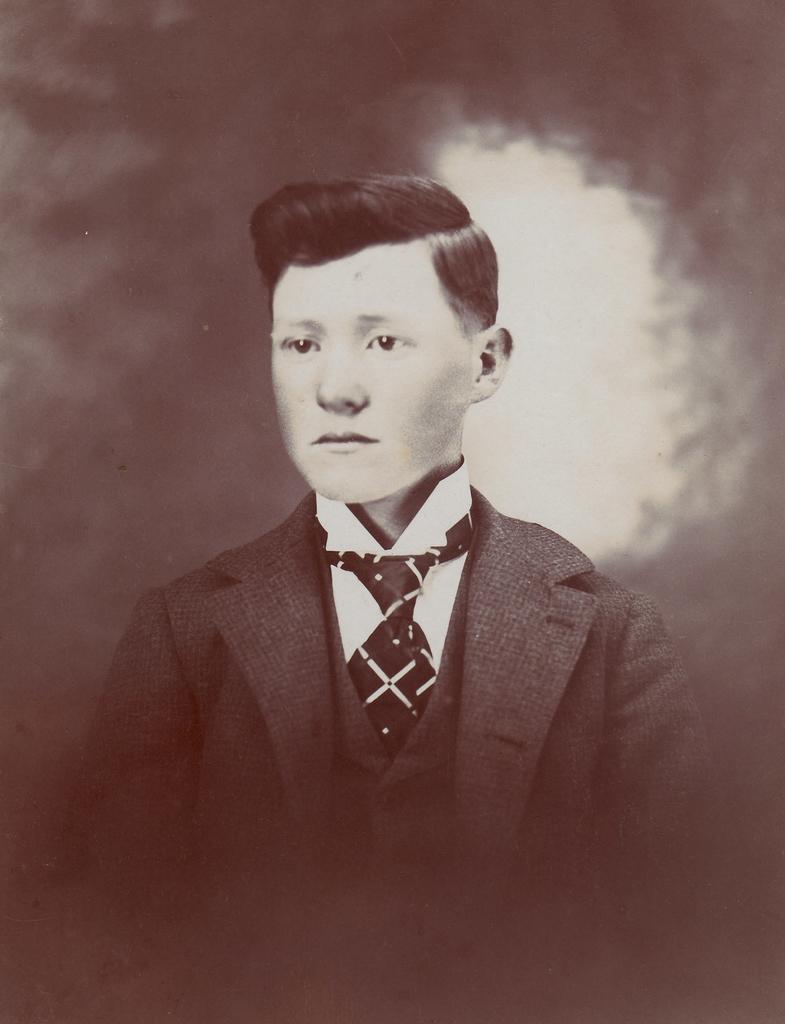Describe this image in one or two sentences. In this picture we can see a person wearing a blazer, shirt and a tie. 